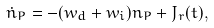<formula> <loc_0><loc_0><loc_500><loc_500>\dot { n } _ { P } = - ( w _ { d } + w _ { i } ) n _ { P } + J _ { r } ( t ) ,</formula> 